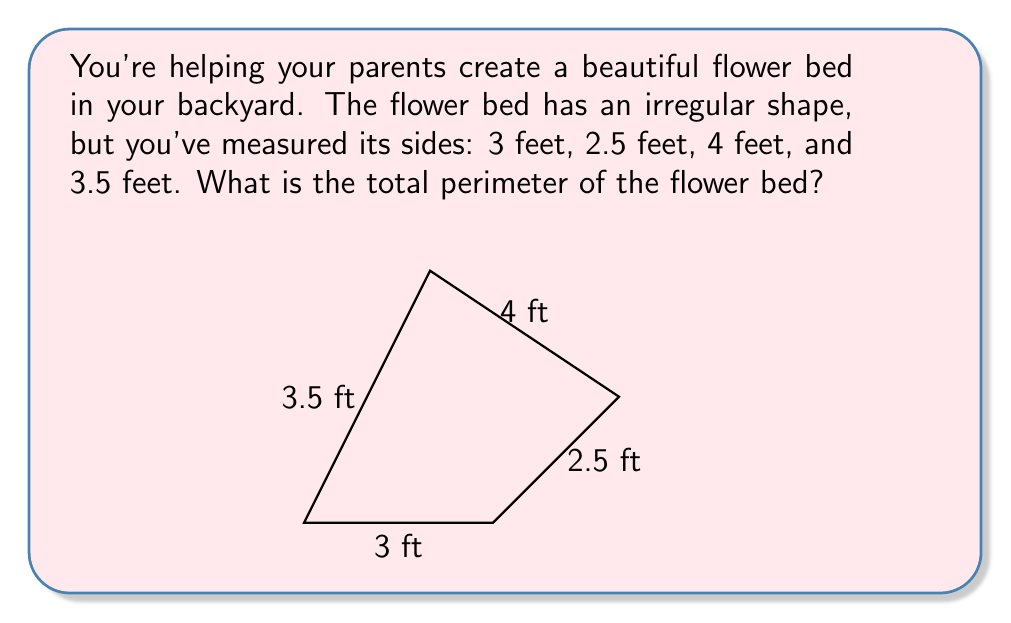Help me with this question. Let's solve this step by step:

1. First, we need to understand what perimeter means. The perimeter is the distance around the outside of a shape.

2. For our flower bed, we have four sides with different lengths:
   Side 1: 3 feet
   Side 2: 2.5 feet
   Side 3: 4 feet
   Side 4: 3.5 feet

3. To find the total perimeter, we need to add up the lengths of all sides:

   $$ \text{Perimeter} = 3 + 2.5 + 4 + 3.5 $$

4. Now, let's do the addition:
   $$ 3 + 2.5 + 4 + 3.5 = 13 $$

5. Therefore, the total perimeter of the flower bed is 13 feet.

This means if you were to walk around the entire flower bed, following its edge, you would travel a total distance of 13 feet!
Answer: 13 feet 